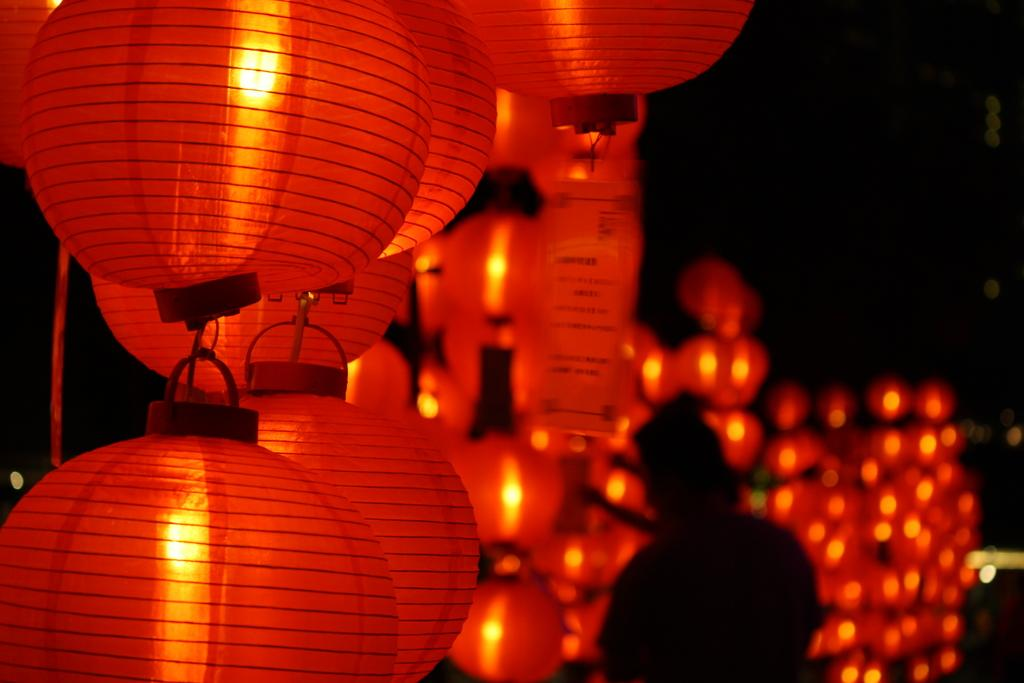What type of objects are present in the picture? There are red balloons in the picture. What is unique about these balloons? Each balloon has a light inside. Can you describe the person in the image? There is a person standing beside the lights in the front of the image. What type of temper does the horse have in the image? There is no horse present in the image; it features red balloons with lights inside and a person standing beside them. 